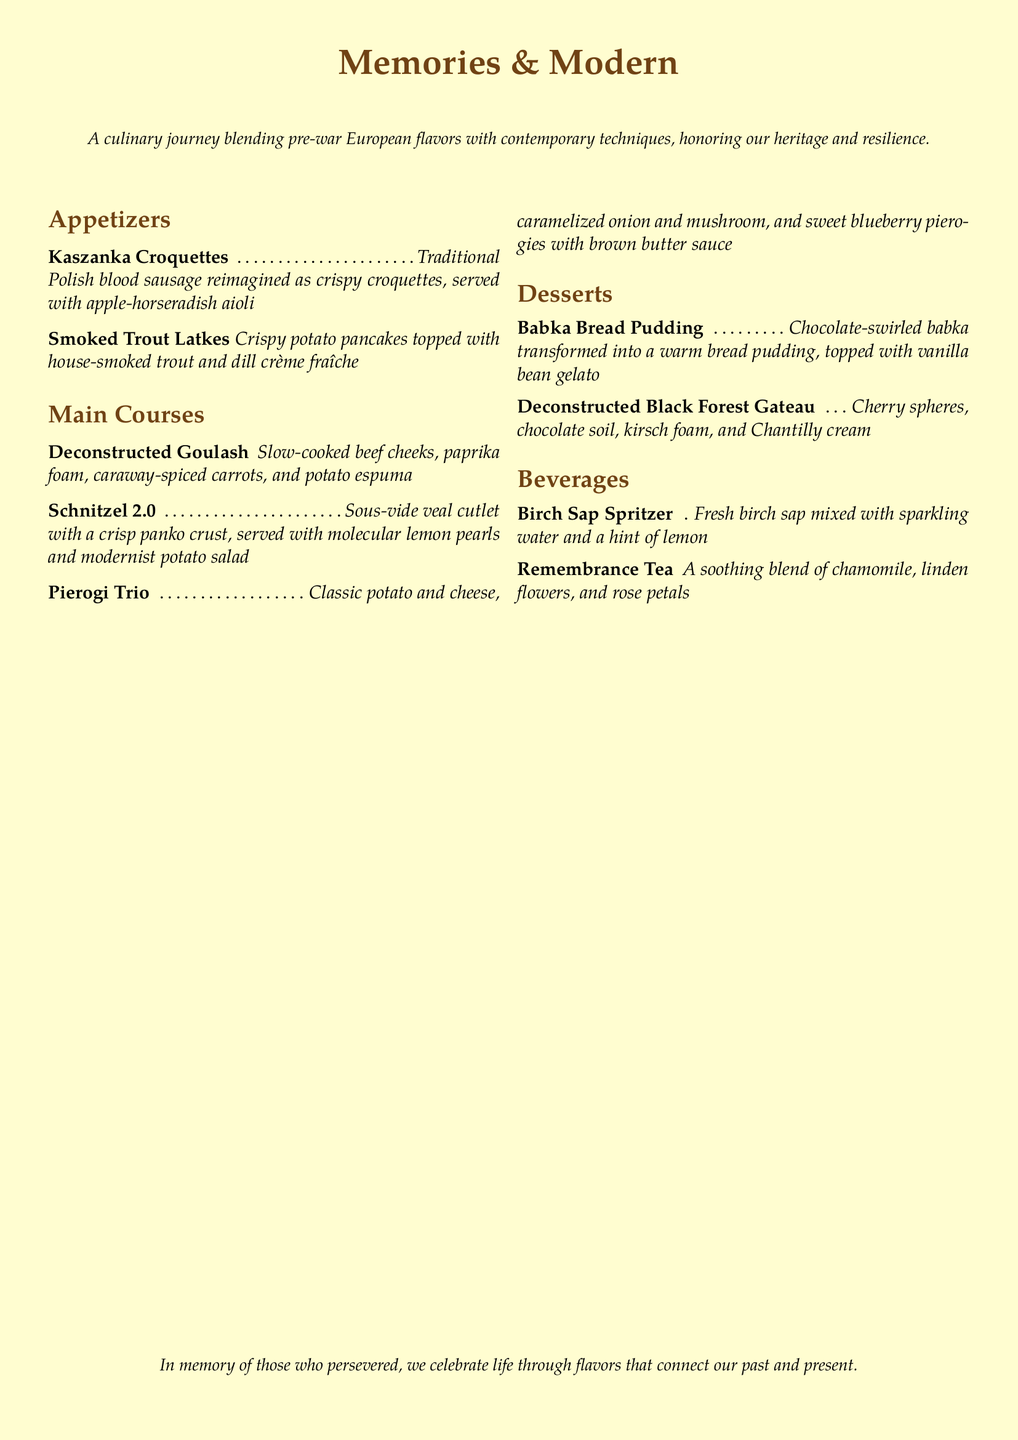What is the name of the restaurant menu? The name of the restaurant menu is stated at the top of the document.
Answer: Memories & Modern How many appetizers are listed on the menu? The number of appetizers can be counted from the appetizers section of the menu.
Answer: 2 What is the main ingredient in the Kaszanka Croquettes? The main ingredient is part of the description for the Kaszanka Croquettes.
Answer: Blood sausage What modern technique is used in the Schnitzel 2.0? The modern technique mentioned in the description for Schnitzel 2.0 indicates a specific cooking method.
Answer: Sous-vide What is served with the Pierogi Trio? The serving method is included in the description of the Pierogi Trio.
Answer: Brown butter sauce What dessert features chocolate swirls? The dessert that includes chocolate swirls is mentioned in its title and description.
Answer: Babka Bread Pudding Which beverage contains birch sap? The beverage details are found in the Beverages section of the menu.
Answer: Birch Sap Spritzer Which spice is mentioned in the Deconstructed Goulash? The relevant spice can be found in the description of the Deconstructed Goulash.
Answer: Paprika How is the Remembrance Tea described? The description of Remembrance Tea provides details about its ingredients and qualities.
Answer: A soothing blend 